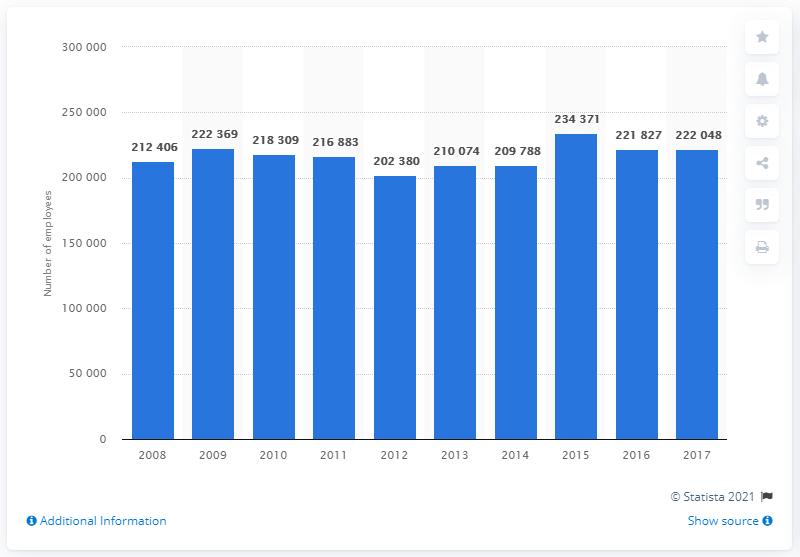Point out several critical features in this image. In 2017, approximately 222,048 individuals were employed in the telecommunications industry. 